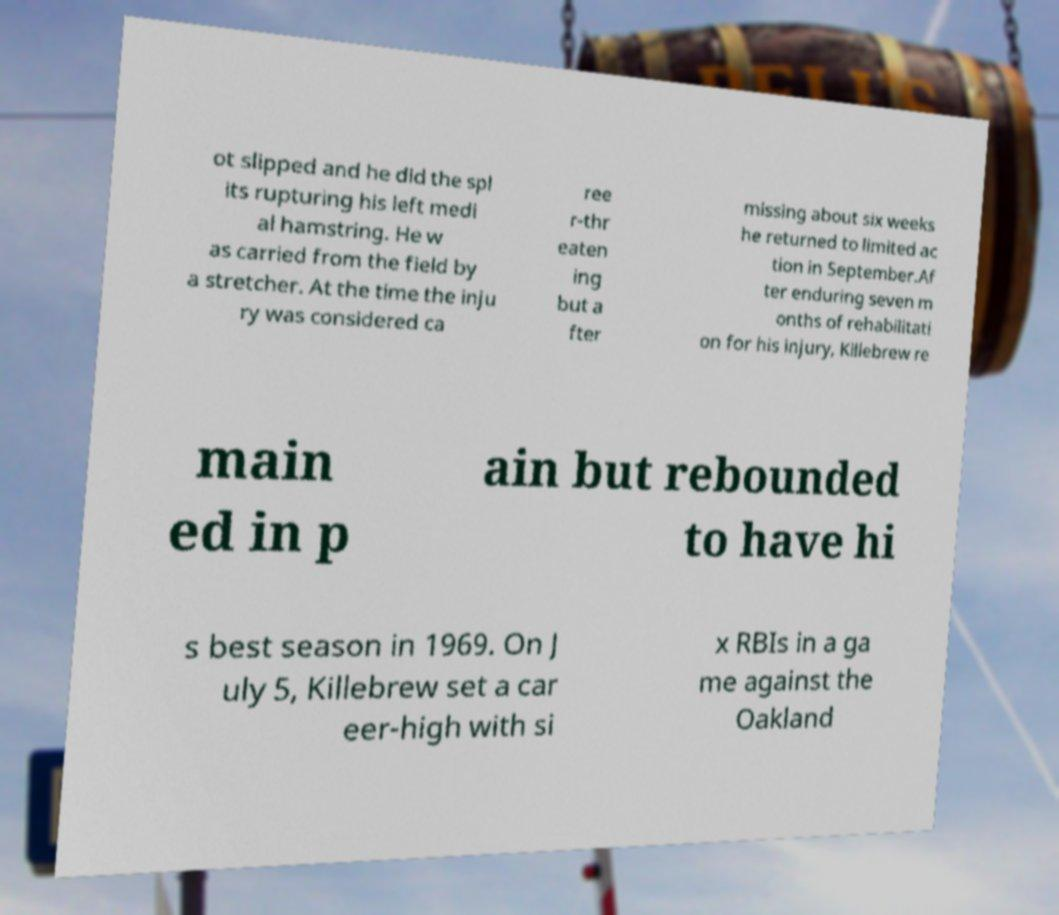I need the written content from this picture converted into text. Can you do that? ot slipped and he did the spl its rupturing his left medi al hamstring. He w as carried from the field by a stretcher. At the time the inju ry was considered ca ree r-thr eaten ing but a fter missing about six weeks he returned to limited ac tion in September.Af ter enduring seven m onths of rehabilitati on for his injury, Killebrew re main ed in p ain but rebounded to have hi s best season in 1969. On J uly 5, Killebrew set a car eer-high with si x RBIs in a ga me against the Oakland 